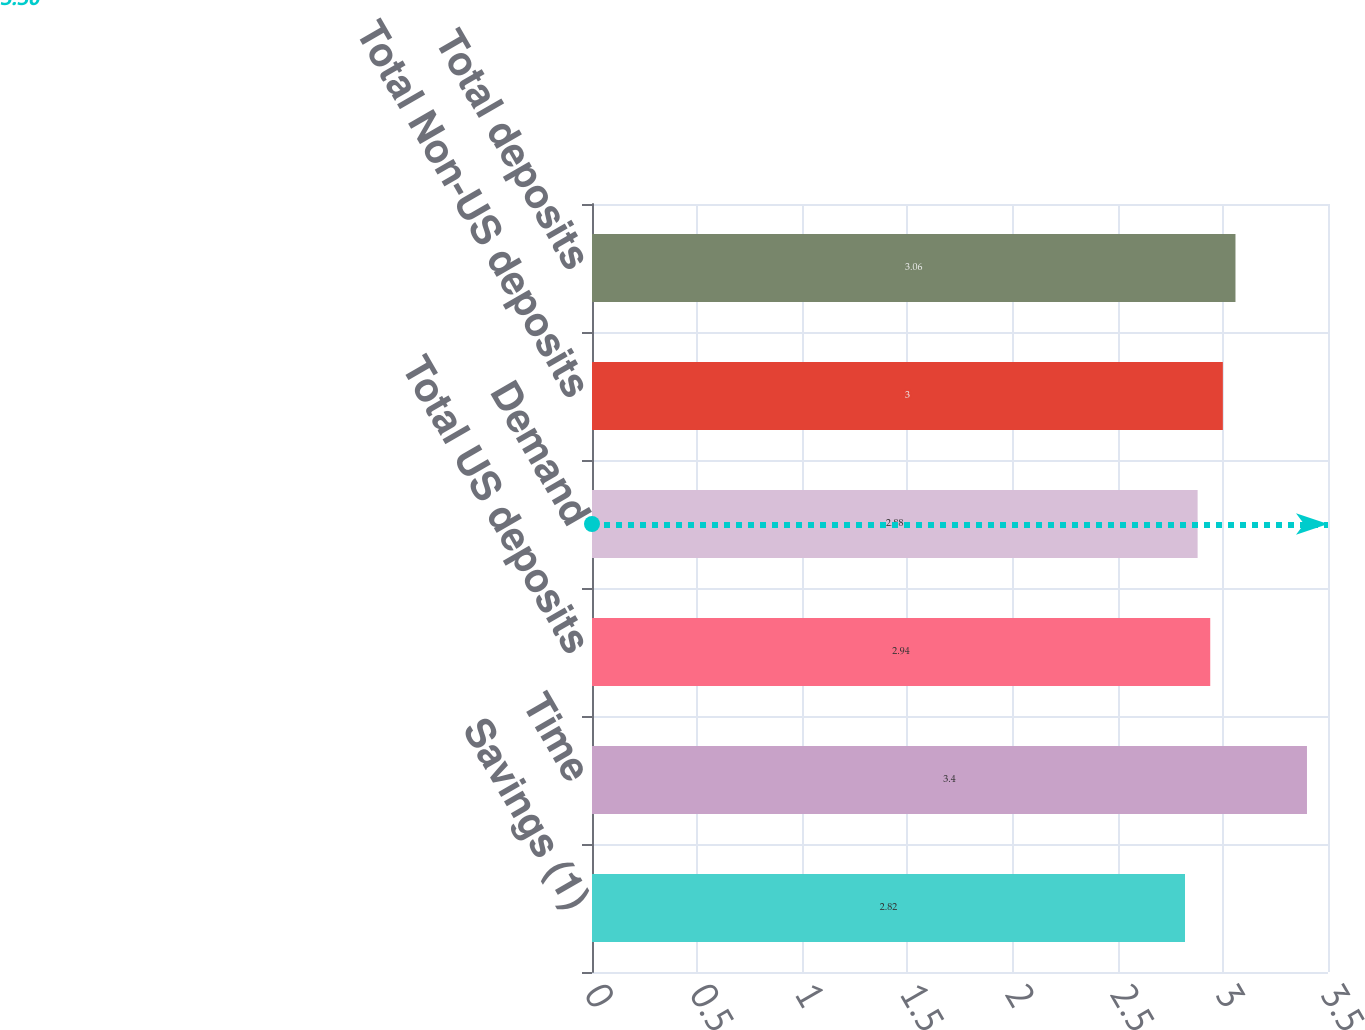Convert chart. <chart><loc_0><loc_0><loc_500><loc_500><bar_chart><fcel>Savings (1)<fcel>Time<fcel>Total US deposits<fcel>Demand<fcel>Total Non-US deposits<fcel>Total deposits<nl><fcel>2.82<fcel>3.4<fcel>2.94<fcel>2.88<fcel>3<fcel>3.06<nl></chart> 